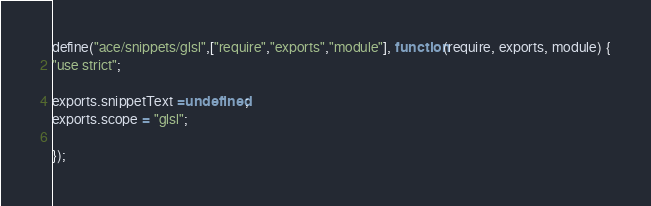<code> <loc_0><loc_0><loc_500><loc_500><_JavaScript_>define("ace/snippets/glsl",["require","exports","module"], function(require, exports, module) {
"use strict";

exports.snippetText =undefined;
exports.scope = "glsl";

});
</code> 